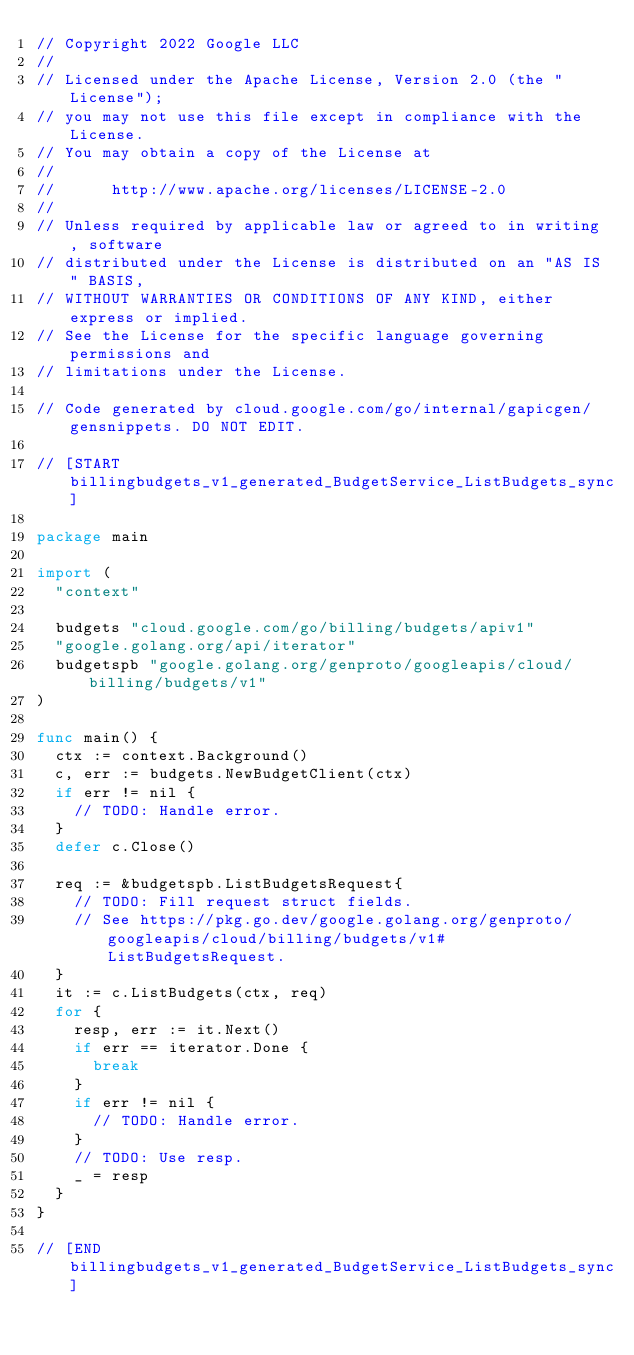Convert code to text. <code><loc_0><loc_0><loc_500><loc_500><_Go_>// Copyright 2022 Google LLC
//
// Licensed under the Apache License, Version 2.0 (the "License");
// you may not use this file except in compliance with the License.
// You may obtain a copy of the License at
//
//      http://www.apache.org/licenses/LICENSE-2.0
//
// Unless required by applicable law or agreed to in writing, software
// distributed under the License is distributed on an "AS IS" BASIS,
// WITHOUT WARRANTIES OR CONDITIONS OF ANY KIND, either express or implied.
// See the License for the specific language governing permissions and
// limitations under the License.

// Code generated by cloud.google.com/go/internal/gapicgen/gensnippets. DO NOT EDIT.

// [START billingbudgets_v1_generated_BudgetService_ListBudgets_sync]

package main

import (
	"context"

	budgets "cloud.google.com/go/billing/budgets/apiv1"
	"google.golang.org/api/iterator"
	budgetspb "google.golang.org/genproto/googleapis/cloud/billing/budgets/v1"
)

func main() {
	ctx := context.Background()
	c, err := budgets.NewBudgetClient(ctx)
	if err != nil {
		// TODO: Handle error.
	}
	defer c.Close()

	req := &budgetspb.ListBudgetsRequest{
		// TODO: Fill request struct fields.
		// See https://pkg.go.dev/google.golang.org/genproto/googleapis/cloud/billing/budgets/v1#ListBudgetsRequest.
	}
	it := c.ListBudgets(ctx, req)
	for {
		resp, err := it.Next()
		if err == iterator.Done {
			break
		}
		if err != nil {
			// TODO: Handle error.
		}
		// TODO: Use resp.
		_ = resp
	}
}

// [END billingbudgets_v1_generated_BudgetService_ListBudgets_sync]
</code> 